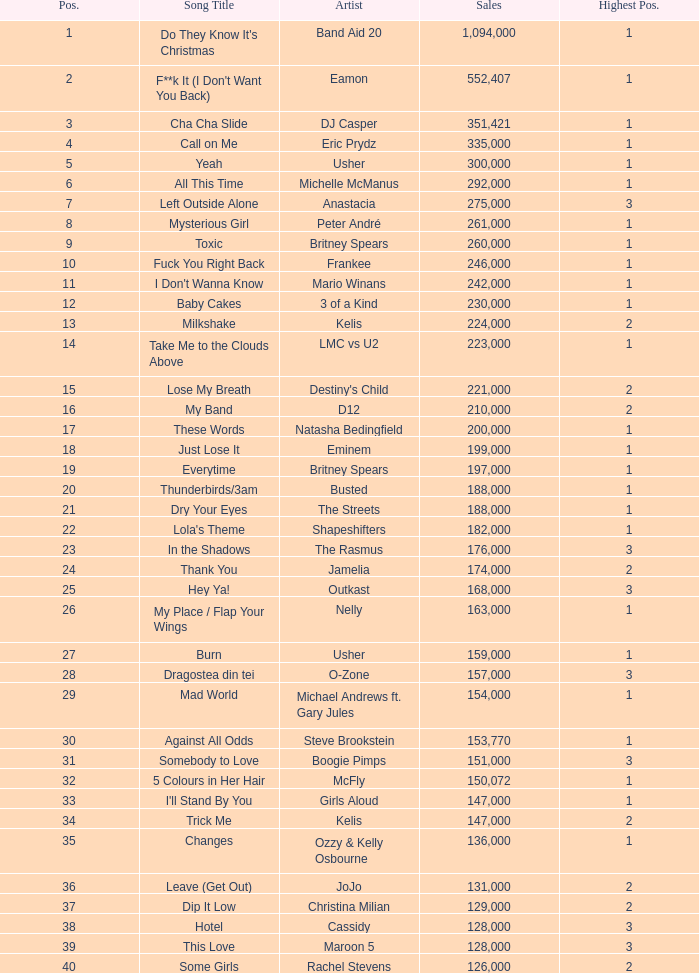What were the sales for Dj Casper when he was in a position lower than 13? 351421.0. 